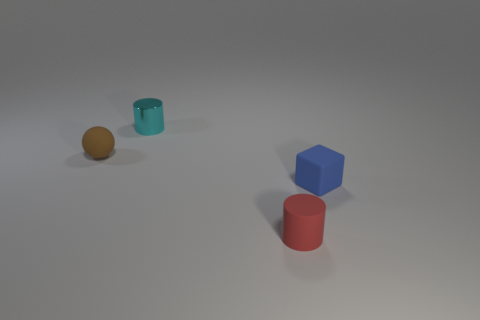Add 4 large green matte spheres. How many objects exist? 8 Subtract all blocks. How many objects are left? 3 Add 4 cylinders. How many cylinders are left? 6 Add 3 tiny matte cubes. How many tiny matte cubes exist? 4 Subtract 1 cyan cylinders. How many objects are left? 3 Subtract all red cylinders. Subtract all tiny cyan objects. How many objects are left? 2 